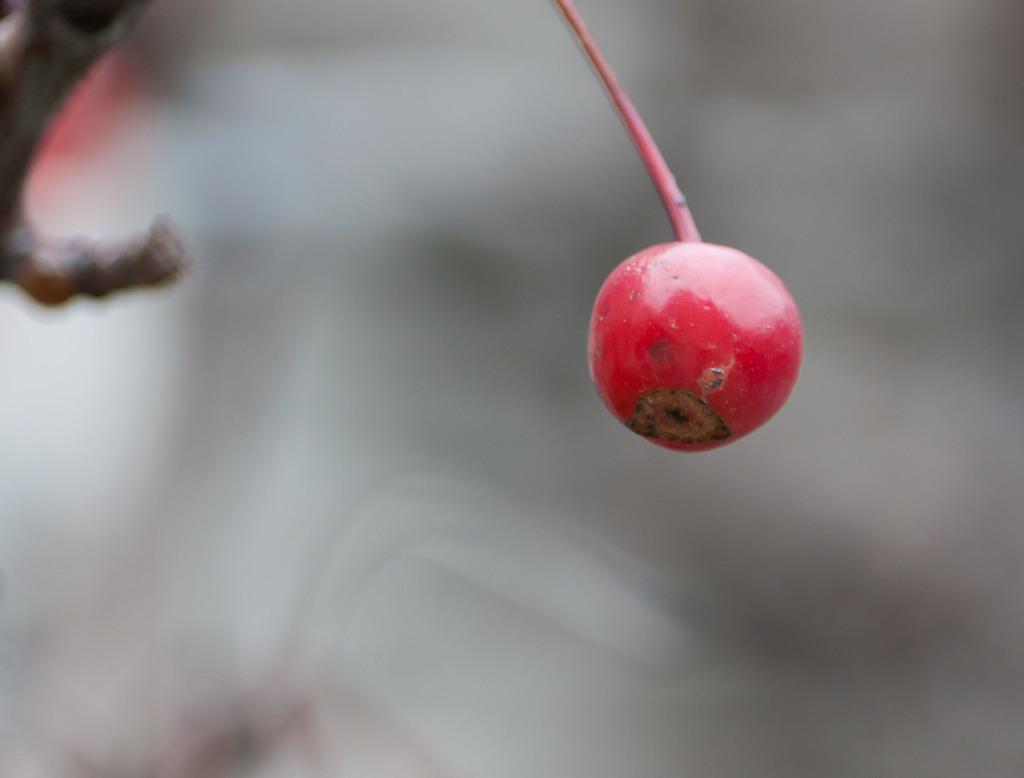What type of photography technique is used in the image? The image is a macro photography. What is the main subject of the macro photography? The subject of the macro photography is a fruit. How is the background of the image depicted? The background of the image is blurred. How many clouds can be seen in the image? There are no clouds present in the image, as it is a macro photography of a fruit. What type of question is being asked in the image? There is no question being asked in the image, as it is a photograph of a fruit. 